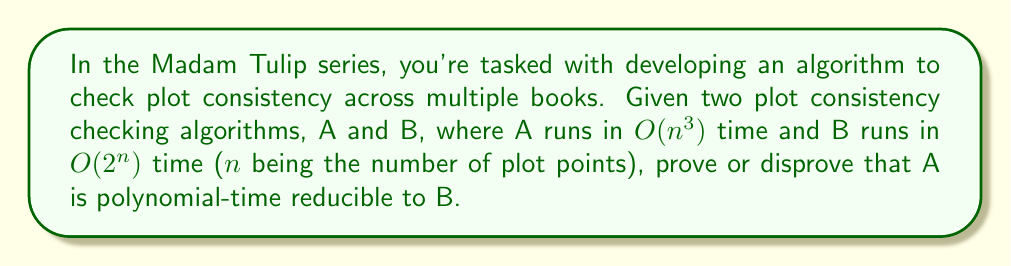Could you help me with this problem? To determine if algorithm A is polynomial-time reducible to algorithm B, we need to consider the following steps:

1. Definition of polynomial-time reducibility:
   Algorithm A is polynomial-time reducible to algorithm B if there exists a polynomial-time function f such that for all inputs x:
   A(x) = B(f(x))

2. Running times:
   - Algorithm A: $O(n^3)$
   - Algorithm B: $O(2^n)$

3. Polynomial-time reduction:
   For A to be polynomial-time reducible to B, we need to find a polynomial-time function f that transforms the input of A into an input for B, such that B(f(x)) produces the same result as A(x).

4. Impossibility proof:
   - Assume there exists such a polynomial-time reduction f.
   - Let the running time of f be $O(n^k)$ for some constant k.
   - The total running time of B(f(x)) would be $O(2^{f(n)})$.
   - For the reduction to be valid, we must have:
     $O(n^3) = O(2^{f(n)})$

   However, this equality cannot hold for all n because:
   - The left side (A's running time) is polynomial.
   - The right side (B's running time after reduction) is exponential.

5. Contradiction:
   No polynomial-time function f can transform the input in such a way that B's exponential running time becomes equivalent to A's polynomial running time for all inputs.

Therefore, algorithm A is not polynomial-time reducible to algorithm B.
Answer: Algorithm A is not polynomial-time reducible to algorithm B. 